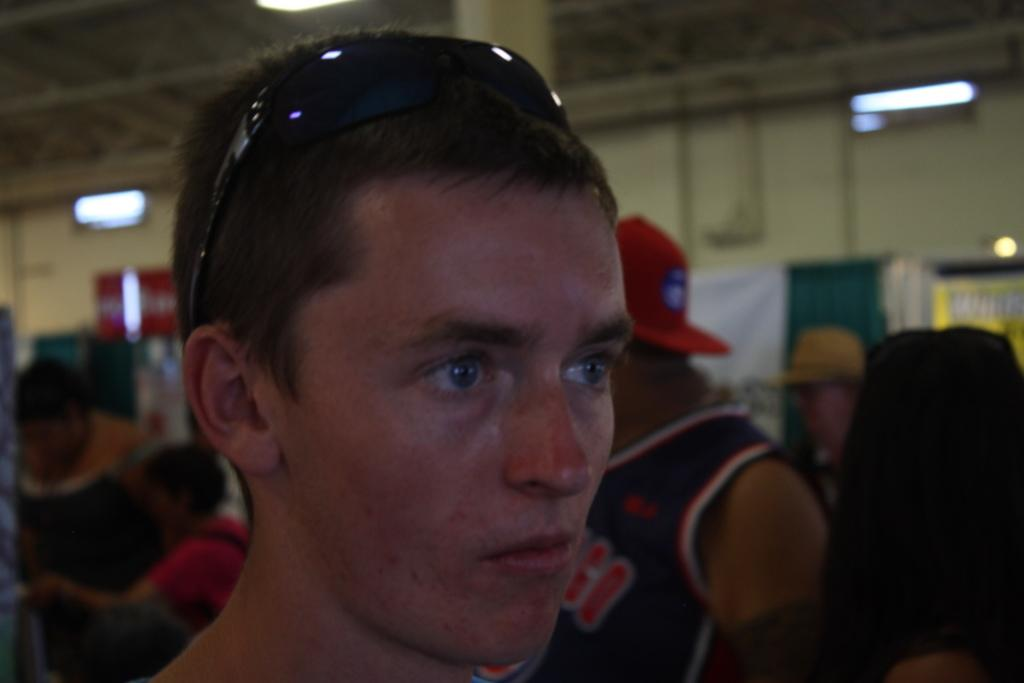What is the main subject of the image? There is a person standing in the middle of the image. Can you describe the surroundings of the person? There are people in the background of the image and a wall is visible. What else can be seen in the image? There are lights in the image. How many amusement rides are present in the image? There are no amusement rides present in the image. Can you tell me the amount of touch required to interact with the lights in the image? The image does not provide information about the type of lights or how they are controlled, so it is impossible to determine the amount of touch required to interact with them. 